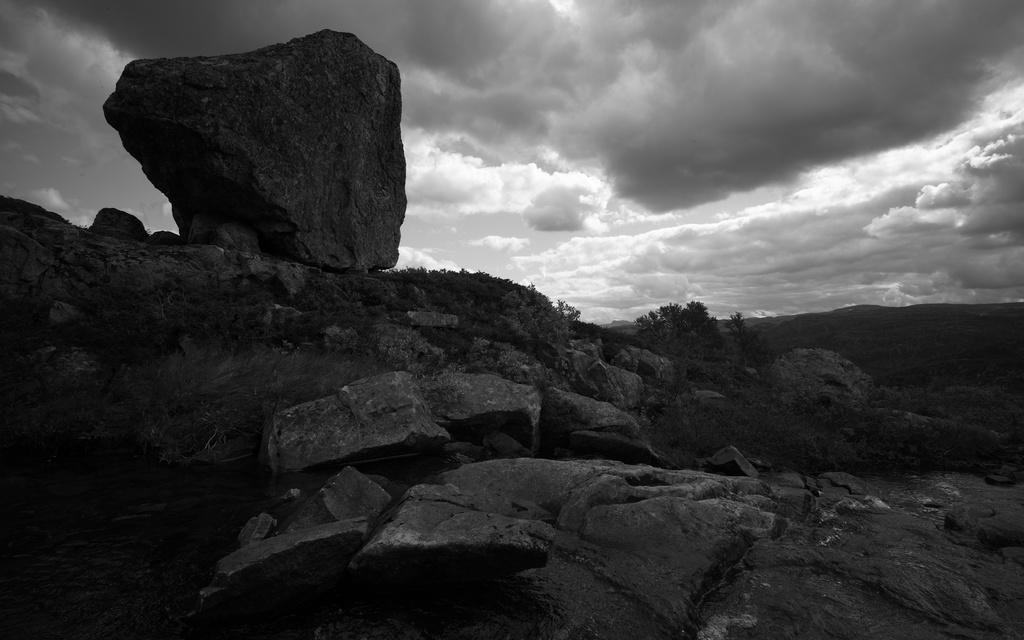What is the color scheme of the image? The image is black and white. What type of natural elements can be seen in the image? There are rocks, plants, and sand visible in the image. What else can be seen in the image besides natural elements? There are other objects in the image. What is visible at the top of the image? The sky is visible at the top of the image. How many cattle are grazing in the image? There are no cattle present in the image. What type of picture is this, a painting or a photograph? The information provided does not specify whether the image is a painting or a photograph. --- Facts: 1. There is a person sitting on a chair in the image. 2. The person is holding a book. 3. The book has a red cover. 4. There is a table next to the chair. 5. There is a lamp on the table. Absurd Topics: parrot, ocean, bicycle Conversation: What is the person in the image doing? The person is sitting on a chair in the image. What is the person holding? The person is holding a book. What color is the book's cover? The book has a red cover. What is located next to the chair? There is a table next to the chair. What object is on the table? There is a lamp on the table. Reasoning: Let's think step by step in order to produce the conversation. We start by identifying the main subject in the image, which is the person sitting on a chair. Then, we describe what the person is holding, which is a book with a red cover. Next, we mention the presence of a table next to the chair. Finally, we acknowledge the presence of a lamp on the table. Absurd Question/Answer: Can you see any parrots flying over the ocean in the image? There are no parrots or ocean present in the image. Is the person riding a bicycle in the image? There is no bicycle present in the image. 